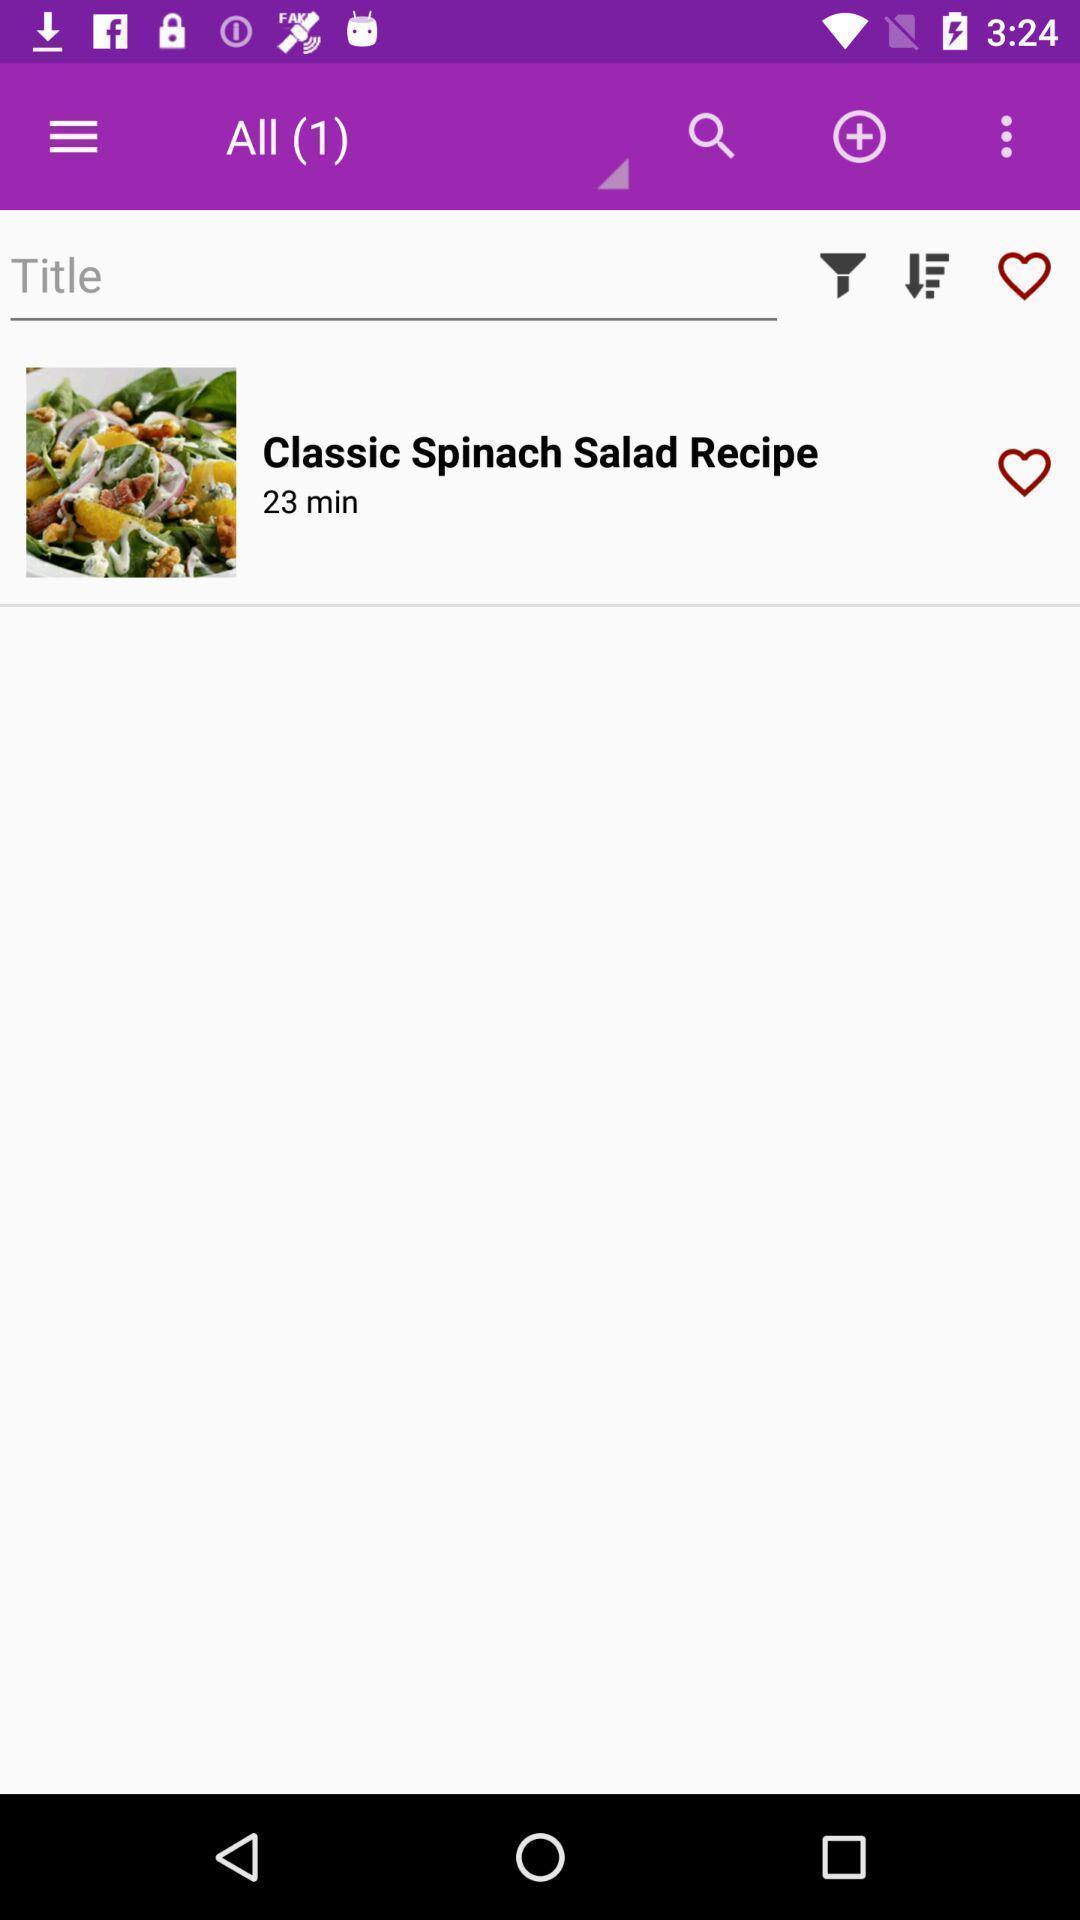Tell me what you see in this picture. Page of a food app. 